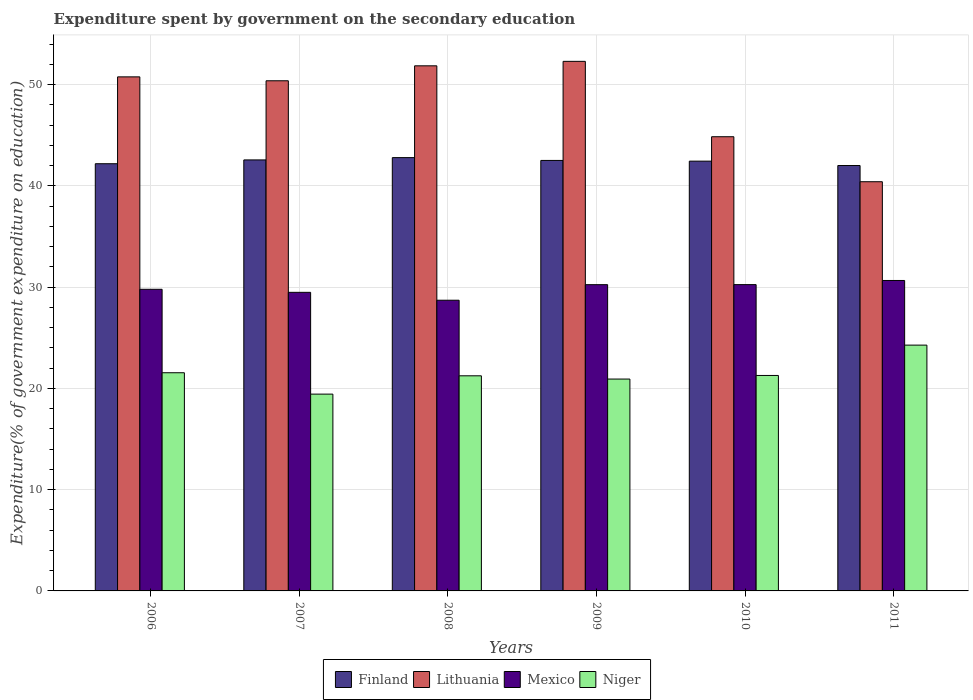Are the number of bars on each tick of the X-axis equal?
Your answer should be very brief. Yes. What is the label of the 5th group of bars from the left?
Keep it short and to the point. 2010. In how many cases, is the number of bars for a given year not equal to the number of legend labels?
Give a very brief answer. 0. What is the expenditure spent by government on the secondary education in Mexico in 2006?
Offer a terse response. 29.79. Across all years, what is the maximum expenditure spent by government on the secondary education in Niger?
Provide a succinct answer. 24.28. Across all years, what is the minimum expenditure spent by government on the secondary education in Lithuania?
Offer a terse response. 40.42. In which year was the expenditure spent by government on the secondary education in Lithuania minimum?
Provide a succinct answer. 2011. What is the total expenditure spent by government on the secondary education in Mexico in the graph?
Offer a terse response. 179.16. What is the difference between the expenditure spent by government on the secondary education in Lithuania in 2008 and that in 2011?
Make the answer very short. 11.45. What is the difference between the expenditure spent by government on the secondary education in Niger in 2007 and the expenditure spent by government on the secondary education in Mexico in 2010?
Your answer should be compact. -10.82. What is the average expenditure spent by government on the secondary education in Finland per year?
Offer a very short reply. 42.42. In the year 2010, what is the difference between the expenditure spent by government on the secondary education in Finland and expenditure spent by government on the secondary education in Mexico?
Offer a very short reply. 12.19. What is the ratio of the expenditure spent by government on the secondary education in Niger in 2006 to that in 2008?
Offer a terse response. 1.01. Is the difference between the expenditure spent by government on the secondary education in Finland in 2008 and 2011 greater than the difference between the expenditure spent by government on the secondary education in Mexico in 2008 and 2011?
Your answer should be compact. Yes. What is the difference between the highest and the second highest expenditure spent by government on the secondary education in Lithuania?
Make the answer very short. 0.44. What is the difference between the highest and the lowest expenditure spent by government on the secondary education in Mexico?
Provide a succinct answer. 1.95. Is the sum of the expenditure spent by government on the secondary education in Finland in 2006 and 2007 greater than the maximum expenditure spent by government on the secondary education in Niger across all years?
Your response must be concise. Yes. Is it the case that in every year, the sum of the expenditure spent by government on the secondary education in Lithuania and expenditure spent by government on the secondary education in Niger is greater than the sum of expenditure spent by government on the secondary education in Mexico and expenditure spent by government on the secondary education in Finland?
Your answer should be very brief. Yes. What does the 2nd bar from the left in 2011 represents?
Ensure brevity in your answer.  Lithuania. How many bars are there?
Your answer should be very brief. 24. How many years are there in the graph?
Ensure brevity in your answer.  6. What is the difference between two consecutive major ticks on the Y-axis?
Give a very brief answer. 10. What is the title of the graph?
Provide a succinct answer. Expenditure spent by government on the secondary education. What is the label or title of the Y-axis?
Offer a terse response. Expenditure(% of government expenditure on education). What is the Expenditure(% of government expenditure on education) of Finland in 2006?
Offer a terse response. 42.19. What is the Expenditure(% of government expenditure on education) in Lithuania in 2006?
Ensure brevity in your answer.  50.77. What is the Expenditure(% of government expenditure on education) of Mexico in 2006?
Ensure brevity in your answer.  29.79. What is the Expenditure(% of government expenditure on education) of Niger in 2006?
Give a very brief answer. 21.55. What is the Expenditure(% of government expenditure on education) in Finland in 2007?
Offer a terse response. 42.57. What is the Expenditure(% of government expenditure on education) in Lithuania in 2007?
Offer a terse response. 50.39. What is the Expenditure(% of government expenditure on education) in Mexico in 2007?
Your answer should be compact. 29.49. What is the Expenditure(% of government expenditure on education) of Niger in 2007?
Provide a short and direct response. 19.44. What is the Expenditure(% of government expenditure on education) in Finland in 2008?
Give a very brief answer. 42.8. What is the Expenditure(% of government expenditure on education) in Lithuania in 2008?
Keep it short and to the point. 51.86. What is the Expenditure(% of government expenditure on education) of Mexico in 2008?
Give a very brief answer. 28.71. What is the Expenditure(% of government expenditure on education) in Niger in 2008?
Provide a short and direct response. 21.25. What is the Expenditure(% of government expenditure on education) of Finland in 2009?
Your answer should be compact. 42.52. What is the Expenditure(% of government expenditure on education) of Lithuania in 2009?
Your answer should be very brief. 52.3. What is the Expenditure(% of government expenditure on education) in Mexico in 2009?
Give a very brief answer. 30.25. What is the Expenditure(% of government expenditure on education) of Niger in 2009?
Make the answer very short. 20.93. What is the Expenditure(% of government expenditure on education) of Finland in 2010?
Your answer should be very brief. 42.45. What is the Expenditure(% of government expenditure on education) of Lithuania in 2010?
Your response must be concise. 44.86. What is the Expenditure(% of government expenditure on education) of Mexico in 2010?
Give a very brief answer. 30.25. What is the Expenditure(% of government expenditure on education) in Niger in 2010?
Your answer should be compact. 21.28. What is the Expenditure(% of government expenditure on education) in Finland in 2011?
Your response must be concise. 42.02. What is the Expenditure(% of government expenditure on education) in Lithuania in 2011?
Your answer should be very brief. 40.42. What is the Expenditure(% of government expenditure on education) in Mexico in 2011?
Make the answer very short. 30.66. What is the Expenditure(% of government expenditure on education) of Niger in 2011?
Offer a terse response. 24.28. Across all years, what is the maximum Expenditure(% of government expenditure on education) in Finland?
Keep it short and to the point. 42.8. Across all years, what is the maximum Expenditure(% of government expenditure on education) of Lithuania?
Ensure brevity in your answer.  52.3. Across all years, what is the maximum Expenditure(% of government expenditure on education) in Mexico?
Give a very brief answer. 30.66. Across all years, what is the maximum Expenditure(% of government expenditure on education) of Niger?
Offer a very short reply. 24.28. Across all years, what is the minimum Expenditure(% of government expenditure on education) in Finland?
Keep it short and to the point. 42.02. Across all years, what is the minimum Expenditure(% of government expenditure on education) in Lithuania?
Your answer should be compact. 40.42. Across all years, what is the minimum Expenditure(% of government expenditure on education) in Mexico?
Your answer should be very brief. 28.71. Across all years, what is the minimum Expenditure(% of government expenditure on education) in Niger?
Your answer should be compact. 19.44. What is the total Expenditure(% of government expenditure on education) of Finland in the graph?
Offer a very short reply. 254.54. What is the total Expenditure(% of government expenditure on education) in Lithuania in the graph?
Provide a short and direct response. 290.6. What is the total Expenditure(% of government expenditure on education) of Mexico in the graph?
Provide a short and direct response. 179.16. What is the total Expenditure(% of government expenditure on education) in Niger in the graph?
Make the answer very short. 128.72. What is the difference between the Expenditure(% of government expenditure on education) in Finland in 2006 and that in 2007?
Your response must be concise. -0.38. What is the difference between the Expenditure(% of government expenditure on education) in Lithuania in 2006 and that in 2007?
Provide a short and direct response. 0.39. What is the difference between the Expenditure(% of government expenditure on education) of Mexico in 2006 and that in 2007?
Your response must be concise. 0.3. What is the difference between the Expenditure(% of government expenditure on education) of Niger in 2006 and that in 2007?
Your answer should be compact. 2.11. What is the difference between the Expenditure(% of government expenditure on education) of Finland in 2006 and that in 2008?
Offer a very short reply. -0.6. What is the difference between the Expenditure(% of government expenditure on education) of Lithuania in 2006 and that in 2008?
Offer a terse response. -1.09. What is the difference between the Expenditure(% of government expenditure on education) in Mexico in 2006 and that in 2008?
Give a very brief answer. 1.08. What is the difference between the Expenditure(% of government expenditure on education) of Niger in 2006 and that in 2008?
Provide a short and direct response. 0.3. What is the difference between the Expenditure(% of government expenditure on education) in Finland in 2006 and that in 2009?
Make the answer very short. -0.32. What is the difference between the Expenditure(% of government expenditure on education) in Lithuania in 2006 and that in 2009?
Provide a succinct answer. -1.53. What is the difference between the Expenditure(% of government expenditure on education) of Mexico in 2006 and that in 2009?
Keep it short and to the point. -0.46. What is the difference between the Expenditure(% of government expenditure on education) of Niger in 2006 and that in 2009?
Make the answer very short. 0.62. What is the difference between the Expenditure(% of government expenditure on education) of Finland in 2006 and that in 2010?
Offer a terse response. -0.25. What is the difference between the Expenditure(% of government expenditure on education) in Lithuania in 2006 and that in 2010?
Provide a short and direct response. 5.91. What is the difference between the Expenditure(% of government expenditure on education) of Mexico in 2006 and that in 2010?
Give a very brief answer. -0.46. What is the difference between the Expenditure(% of government expenditure on education) in Niger in 2006 and that in 2010?
Provide a short and direct response. 0.27. What is the difference between the Expenditure(% of government expenditure on education) in Finland in 2006 and that in 2011?
Make the answer very short. 0.18. What is the difference between the Expenditure(% of government expenditure on education) in Lithuania in 2006 and that in 2011?
Your response must be concise. 10.36. What is the difference between the Expenditure(% of government expenditure on education) of Mexico in 2006 and that in 2011?
Provide a succinct answer. -0.87. What is the difference between the Expenditure(% of government expenditure on education) in Niger in 2006 and that in 2011?
Provide a short and direct response. -2.73. What is the difference between the Expenditure(% of government expenditure on education) in Finland in 2007 and that in 2008?
Provide a succinct answer. -0.23. What is the difference between the Expenditure(% of government expenditure on education) of Lithuania in 2007 and that in 2008?
Provide a short and direct response. -1.48. What is the difference between the Expenditure(% of government expenditure on education) in Mexico in 2007 and that in 2008?
Give a very brief answer. 0.78. What is the difference between the Expenditure(% of government expenditure on education) in Niger in 2007 and that in 2008?
Offer a terse response. -1.81. What is the difference between the Expenditure(% of government expenditure on education) of Finland in 2007 and that in 2009?
Offer a very short reply. 0.05. What is the difference between the Expenditure(% of government expenditure on education) of Lithuania in 2007 and that in 2009?
Provide a short and direct response. -1.92. What is the difference between the Expenditure(% of government expenditure on education) of Mexico in 2007 and that in 2009?
Give a very brief answer. -0.76. What is the difference between the Expenditure(% of government expenditure on education) in Niger in 2007 and that in 2009?
Provide a succinct answer. -1.49. What is the difference between the Expenditure(% of government expenditure on education) of Finland in 2007 and that in 2010?
Offer a very short reply. 0.12. What is the difference between the Expenditure(% of government expenditure on education) in Lithuania in 2007 and that in 2010?
Provide a succinct answer. 5.53. What is the difference between the Expenditure(% of government expenditure on education) in Mexico in 2007 and that in 2010?
Your response must be concise. -0.76. What is the difference between the Expenditure(% of government expenditure on education) in Niger in 2007 and that in 2010?
Offer a very short reply. -1.84. What is the difference between the Expenditure(% of government expenditure on education) of Finland in 2007 and that in 2011?
Your answer should be compact. 0.55. What is the difference between the Expenditure(% of government expenditure on education) of Lithuania in 2007 and that in 2011?
Offer a terse response. 9.97. What is the difference between the Expenditure(% of government expenditure on education) of Mexico in 2007 and that in 2011?
Make the answer very short. -1.17. What is the difference between the Expenditure(% of government expenditure on education) of Niger in 2007 and that in 2011?
Make the answer very short. -4.84. What is the difference between the Expenditure(% of government expenditure on education) in Finland in 2008 and that in 2009?
Your response must be concise. 0.28. What is the difference between the Expenditure(% of government expenditure on education) in Lithuania in 2008 and that in 2009?
Give a very brief answer. -0.44. What is the difference between the Expenditure(% of government expenditure on education) in Mexico in 2008 and that in 2009?
Your answer should be compact. -1.54. What is the difference between the Expenditure(% of government expenditure on education) in Niger in 2008 and that in 2009?
Your answer should be very brief. 0.32. What is the difference between the Expenditure(% of government expenditure on education) in Finland in 2008 and that in 2010?
Offer a very short reply. 0.35. What is the difference between the Expenditure(% of government expenditure on education) of Lithuania in 2008 and that in 2010?
Provide a short and direct response. 7. What is the difference between the Expenditure(% of government expenditure on education) of Mexico in 2008 and that in 2010?
Offer a terse response. -1.54. What is the difference between the Expenditure(% of government expenditure on education) in Niger in 2008 and that in 2010?
Your answer should be very brief. -0.03. What is the difference between the Expenditure(% of government expenditure on education) in Finland in 2008 and that in 2011?
Provide a short and direct response. 0.78. What is the difference between the Expenditure(% of government expenditure on education) in Lithuania in 2008 and that in 2011?
Make the answer very short. 11.45. What is the difference between the Expenditure(% of government expenditure on education) in Mexico in 2008 and that in 2011?
Your answer should be compact. -1.95. What is the difference between the Expenditure(% of government expenditure on education) in Niger in 2008 and that in 2011?
Provide a succinct answer. -3.03. What is the difference between the Expenditure(% of government expenditure on education) in Finland in 2009 and that in 2010?
Ensure brevity in your answer.  0.07. What is the difference between the Expenditure(% of government expenditure on education) of Lithuania in 2009 and that in 2010?
Keep it short and to the point. 7.45. What is the difference between the Expenditure(% of government expenditure on education) of Mexico in 2009 and that in 2010?
Offer a very short reply. -0.01. What is the difference between the Expenditure(% of government expenditure on education) in Niger in 2009 and that in 2010?
Offer a terse response. -0.35. What is the difference between the Expenditure(% of government expenditure on education) of Finland in 2009 and that in 2011?
Keep it short and to the point. 0.5. What is the difference between the Expenditure(% of government expenditure on education) in Lithuania in 2009 and that in 2011?
Make the answer very short. 11.89. What is the difference between the Expenditure(% of government expenditure on education) of Mexico in 2009 and that in 2011?
Your answer should be very brief. -0.41. What is the difference between the Expenditure(% of government expenditure on education) of Niger in 2009 and that in 2011?
Your answer should be very brief. -3.35. What is the difference between the Expenditure(% of government expenditure on education) of Finland in 2010 and that in 2011?
Keep it short and to the point. 0.43. What is the difference between the Expenditure(% of government expenditure on education) in Lithuania in 2010 and that in 2011?
Ensure brevity in your answer.  4.44. What is the difference between the Expenditure(% of government expenditure on education) of Mexico in 2010 and that in 2011?
Your response must be concise. -0.41. What is the difference between the Expenditure(% of government expenditure on education) in Niger in 2010 and that in 2011?
Keep it short and to the point. -3. What is the difference between the Expenditure(% of government expenditure on education) of Finland in 2006 and the Expenditure(% of government expenditure on education) of Lithuania in 2007?
Ensure brevity in your answer.  -8.19. What is the difference between the Expenditure(% of government expenditure on education) of Finland in 2006 and the Expenditure(% of government expenditure on education) of Mexico in 2007?
Your answer should be very brief. 12.7. What is the difference between the Expenditure(% of government expenditure on education) of Finland in 2006 and the Expenditure(% of government expenditure on education) of Niger in 2007?
Offer a very short reply. 22.76. What is the difference between the Expenditure(% of government expenditure on education) in Lithuania in 2006 and the Expenditure(% of government expenditure on education) in Mexico in 2007?
Offer a terse response. 21.28. What is the difference between the Expenditure(% of government expenditure on education) of Lithuania in 2006 and the Expenditure(% of government expenditure on education) of Niger in 2007?
Provide a short and direct response. 31.33. What is the difference between the Expenditure(% of government expenditure on education) of Mexico in 2006 and the Expenditure(% of government expenditure on education) of Niger in 2007?
Make the answer very short. 10.35. What is the difference between the Expenditure(% of government expenditure on education) of Finland in 2006 and the Expenditure(% of government expenditure on education) of Lithuania in 2008?
Offer a terse response. -9.67. What is the difference between the Expenditure(% of government expenditure on education) in Finland in 2006 and the Expenditure(% of government expenditure on education) in Mexico in 2008?
Your answer should be very brief. 13.48. What is the difference between the Expenditure(% of government expenditure on education) of Finland in 2006 and the Expenditure(% of government expenditure on education) of Niger in 2008?
Your response must be concise. 20.95. What is the difference between the Expenditure(% of government expenditure on education) of Lithuania in 2006 and the Expenditure(% of government expenditure on education) of Mexico in 2008?
Keep it short and to the point. 22.06. What is the difference between the Expenditure(% of government expenditure on education) of Lithuania in 2006 and the Expenditure(% of government expenditure on education) of Niger in 2008?
Give a very brief answer. 29.53. What is the difference between the Expenditure(% of government expenditure on education) in Mexico in 2006 and the Expenditure(% of government expenditure on education) in Niger in 2008?
Your answer should be very brief. 8.54. What is the difference between the Expenditure(% of government expenditure on education) in Finland in 2006 and the Expenditure(% of government expenditure on education) in Lithuania in 2009?
Provide a short and direct response. -10.11. What is the difference between the Expenditure(% of government expenditure on education) in Finland in 2006 and the Expenditure(% of government expenditure on education) in Mexico in 2009?
Keep it short and to the point. 11.95. What is the difference between the Expenditure(% of government expenditure on education) in Finland in 2006 and the Expenditure(% of government expenditure on education) in Niger in 2009?
Provide a succinct answer. 21.27. What is the difference between the Expenditure(% of government expenditure on education) of Lithuania in 2006 and the Expenditure(% of government expenditure on education) of Mexico in 2009?
Give a very brief answer. 20.52. What is the difference between the Expenditure(% of government expenditure on education) of Lithuania in 2006 and the Expenditure(% of government expenditure on education) of Niger in 2009?
Offer a terse response. 29.85. What is the difference between the Expenditure(% of government expenditure on education) of Mexico in 2006 and the Expenditure(% of government expenditure on education) of Niger in 2009?
Make the answer very short. 8.86. What is the difference between the Expenditure(% of government expenditure on education) in Finland in 2006 and the Expenditure(% of government expenditure on education) in Lithuania in 2010?
Offer a terse response. -2.67. What is the difference between the Expenditure(% of government expenditure on education) in Finland in 2006 and the Expenditure(% of government expenditure on education) in Mexico in 2010?
Ensure brevity in your answer.  11.94. What is the difference between the Expenditure(% of government expenditure on education) of Finland in 2006 and the Expenditure(% of government expenditure on education) of Niger in 2010?
Ensure brevity in your answer.  20.91. What is the difference between the Expenditure(% of government expenditure on education) of Lithuania in 2006 and the Expenditure(% of government expenditure on education) of Mexico in 2010?
Provide a short and direct response. 20.52. What is the difference between the Expenditure(% of government expenditure on education) of Lithuania in 2006 and the Expenditure(% of government expenditure on education) of Niger in 2010?
Offer a very short reply. 29.49. What is the difference between the Expenditure(% of government expenditure on education) in Mexico in 2006 and the Expenditure(% of government expenditure on education) in Niger in 2010?
Give a very brief answer. 8.51. What is the difference between the Expenditure(% of government expenditure on education) in Finland in 2006 and the Expenditure(% of government expenditure on education) in Lithuania in 2011?
Your response must be concise. 1.78. What is the difference between the Expenditure(% of government expenditure on education) of Finland in 2006 and the Expenditure(% of government expenditure on education) of Mexico in 2011?
Your answer should be very brief. 11.53. What is the difference between the Expenditure(% of government expenditure on education) in Finland in 2006 and the Expenditure(% of government expenditure on education) in Niger in 2011?
Offer a terse response. 17.92. What is the difference between the Expenditure(% of government expenditure on education) in Lithuania in 2006 and the Expenditure(% of government expenditure on education) in Mexico in 2011?
Your answer should be very brief. 20.11. What is the difference between the Expenditure(% of government expenditure on education) of Lithuania in 2006 and the Expenditure(% of government expenditure on education) of Niger in 2011?
Offer a terse response. 26.5. What is the difference between the Expenditure(% of government expenditure on education) of Mexico in 2006 and the Expenditure(% of government expenditure on education) of Niger in 2011?
Keep it short and to the point. 5.51. What is the difference between the Expenditure(% of government expenditure on education) in Finland in 2007 and the Expenditure(% of government expenditure on education) in Lithuania in 2008?
Provide a short and direct response. -9.29. What is the difference between the Expenditure(% of government expenditure on education) of Finland in 2007 and the Expenditure(% of government expenditure on education) of Mexico in 2008?
Your answer should be compact. 13.86. What is the difference between the Expenditure(% of government expenditure on education) of Finland in 2007 and the Expenditure(% of government expenditure on education) of Niger in 2008?
Offer a terse response. 21.32. What is the difference between the Expenditure(% of government expenditure on education) of Lithuania in 2007 and the Expenditure(% of government expenditure on education) of Mexico in 2008?
Provide a short and direct response. 21.68. What is the difference between the Expenditure(% of government expenditure on education) of Lithuania in 2007 and the Expenditure(% of government expenditure on education) of Niger in 2008?
Your answer should be very brief. 29.14. What is the difference between the Expenditure(% of government expenditure on education) in Mexico in 2007 and the Expenditure(% of government expenditure on education) in Niger in 2008?
Offer a terse response. 8.24. What is the difference between the Expenditure(% of government expenditure on education) of Finland in 2007 and the Expenditure(% of government expenditure on education) of Lithuania in 2009?
Your answer should be very brief. -9.74. What is the difference between the Expenditure(% of government expenditure on education) in Finland in 2007 and the Expenditure(% of government expenditure on education) in Mexico in 2009?
Offer a very short reply. 12.32. What is the difference between the Expenditure(% of government expenditure on education) of Finland in 2007 and the Expenditure(% of government expenditure on education) of Niger in 2009?
Your answer should be very brief. 21.64. What is the difference between the Expenditure(% of government expenditure on education) in Lithuania in 2007 and the Expenditure(% of government expenditure on education) in Mexico in 2009?
Keep it short and to the point. 20.14. What is the difference between the Expenditure(% of government expenditure on education) in Lithuania in 2007 and the Expenditure(% of government expenditure on education) in Niger in 2009?
Ensure brevity in your answer.  29.46. What is the difference between the Expenditure(% of government expenditure on education) of Mexico in 2007 and the Expenditure(% of government expenditure on education) of Niger in 2009?
Offer a terse response. 8.56. What is the difference between the Expenditure(% of government expenditure on education) in Finland in 2007 and the Expenditure(% of government expenditure on education) in Lithuania in 2010?
Your answer should be very brief. -2.29. What is the difference between the Expenditure(% of government expenditure on education) of Finland in 2007 and the Expenditure(% of government expenditure on education) of Mexico in 2010?
Give a very brief answer. 12.32. What is the difference between the Expenditure(% of government expenditure on education) in Finland in 2007 and the Expenditure(% of government expenditure on education) in Niger in 2010?
Keep it short and to the point. 21.29. What is the difference between the Expenditure(% of government expenditure on education) in Lithuania in 2007 and the Expenditure(% of government expenditure on education) in Mexico in 2010?
Make the answer very short. 20.13. What is the difference between the Expenditure(% of government expenditure on education) of Lithuania in 2007 and the Expenditure(% of government expenditure on education) of Niger in 2010?
Provide a succinct answer. 29.11. What is the difference between the Expenditure(% of government expenditure on education) in Mexico in 2007 and the Expenditure(% of government expenditure on education) in Niger in 2010?
Ensure brevity in your answer.  8.21. What is the difference between the Expenditure(% of government expenditure on education) in Finland in 2007 and the Expenditure(% of government expenditure on education) in Lithuania in 2011?
Ensure brevity in your answer.  2.15. What is the difference between the Expenditure(% of government expenditure on education) of Finland in 2007 and the Expenditure(% of government expenditure on education) of Mexico in 2011?
Keep it short and to the point. 11.91. What is the difference between the Expenditure(% of government expenditure on education) in Finland in 2007 and the Expenditure(% of government expenditure on education) in Niger in 2011?
Offer a terse response. 18.29. What is the difference between the Expenditure(% of government expenditure on education) in Lithuania in 2007 and the Expenditure(% of government expenditure on education) in Mexico in 2011?
Your response must be concise. 19.72. What is the difference between the Expenditure(% of government expenditure on education) of Lithuania in 2007 and the Expenditure(% of government expenditure on education) of Niger in 2011?
Provide a short and direct response. 26.11. What is the difference between the Expenditure(% of government expenditure on education) of Mexico in 2007 and the Expenditure(% of government expenditure on education) of Niger in 2011?
Provide a succinct answer. 5.21. What is the difference between the Expenditure(% of government expenditure on education) of Finland in 2008 and the Expenditure(% of government expenditure on education) of Lithuania in 2009?
Make the answer very short. -9.51. What is the difference between the Expenditure(% of government expenditure on education) in Finland in 2008 and the Expenditure(% of government expenditure on education) in Mexico in 2009?
Your response must be concise. 12.55. What is the difference between the Expenditure(% of government expenditure on education) in Finland in 2008 and the Expenditure(% of government expenditure on education) in Niger in 2009?
Give a very brief answer. 21.87. What is the difference between the Expenditure(% of government expenditure on education) in Lithuania in 2008 and the Expenditure(% of government expenditure on education) in Mexico in 2009?
Offer a terse response. 21.61. What is the difference between the Expenditure(% of government expenditure on education) of Lithuania in 2008 and the Expenditure(% of government expenditure on education) of Niger in 2009?
Your answer should be very brief. 30.94. What is the difference between the Expenditure(% of government expenditure on education) in Mexico in 2008 and the Expenditure(% of government expenditure on education) in Niger in 2009?
Provide a succinct answer. 7.79. What is the difference between the Expenditure(% of government expenditure on education) in Finland in 2008 and the Expenditure(% of government expenditure on education) in Lithuania in 2010?
Your answer should be compact. -2.06. What is the difference between the Expenditure(% of government expenditure on education) in Finland in 2008 and the Expenditure(% of government expenditure on education) in Mexico in 2010?
Keep it short and to the point. 12.54. What is the difference between the Expenditure(% of government expenditure on education) in Finland in 2008 and the Expenditure(% of government expenditure on education) in Niger in 2010?
Provide a succinct answer. 21.52. What is the difference between the Expenditure(% of government expenditure on education) of Lithuania in 2008 and the Expenditure(% of government expenditure on education) of Mexico in 2010?
Keep it short and to the point. 21.61. What is the difference between the Expenditure(% of government expenditure on education) of Lithuania in 2008 and the Expenditure(% of government expenditure on education) of Niger in 2010?
Make the answer very short. 30.58. What is the difference between the Expenditure(% of government expenditure on education) in Mexico in 2008 and the Expenditure(% of government expenditure on education) in Niger in 2010?
Provide a succinct answer. 7.43. What is the difference between the Expenditure(% of government expenditure on education) of Finland in 2008 and the Expenditure(% of government expenditure on education) of Lithuania in 2011?
Ensure brevity in your answer.  2.38. What is the difference between the Expenditure(% of government expenditure on education) in Finland in 2008 and the Expenditure(% of government expenditure on education) in Mexico in 2011?
Your answer should be compact. 12.13. What is the difference between the Expenditure(% of government expenditure on education) of Finland in 2008 and the Expenditure(% of government expenditure on education) of Niger in 2011?
Offer a very short reply. 18.52. What is the difference between the Expenditure(% of government expenditure on education) of Lithuania in 2008 and the Expenditure(% of government expenditure on education) of Mexico in 2011?
Ensure brevity in your answer.  21.2. What is the difference between the Expenditure(% of government expenditure on education) of Lithuania in 2008 and the Expenditure(% of government expenditure on education) of Niger in 2011?
Make the answer very short. 27.58. What is the difference between the Expenditure(% of government expenditure on education) in Mexico in 2008 and the Expenditure(% of government expenditure on education) in Niger in 2011?
Offer a terse response. 4.43. What is the difference between the Expenditure(% of government expenditure on education) in Finland in 2009 and the Expenditure(% of government expenditure on education) in Lithuania in 2010?
Offer a very short reply. -2.34. What is the difference between the Expenditure(% of government expenditure on education) of Finland in 2009 and the Expenditure(% of government expenditure on education) of Mexico in 2010?
Offer a very short reply. 12.26. What is the difference between the Expenditure(% of government expenditure on education) in Finland in 2009 and the Expenditure(% of government expenditure on education) in Niger in 2010?
Give a very brief answer. 21.24. What is the difference between the Expenditure(% of government expenditure on education) of Lithuania in 2009 and the Expenditure(% of government expenditure on education) of Mexico in 2010?
Provide a short and direct response. 22.05. What is the difference between the Expenditure(% of government expenditure on education) in Lithuania in 2009 and the Expenditure(% of government expenditure on education) in Niger in 2010?
Your response must be concise. 31.02. What is the difference between the Expenditure(% of government expenditure on education) in Mexico in 2009 and the Expenditure(% of government expenditure on education) in Niger in 2010?
Give a very brief answer. 8.97. What is the difference between the Expenditure(% of government expenditure on education) of Finland in 2009 and the Expenditure(% of government expenditure on education) of Lithuania in 2011?
Keep it short and to the point. 2.1. What is the difference between the Expenditure(% of government expenditure on education) in Finland in 2009 and the Expenditure(% of government expenditure on education) in Mexico in 2011?
Ensure brevity in your answer.  11.86. What is the difference between the Expenditure(% of government expenditure on education) in Finland in 2009 and the Expenditure(% of government expenditure on education) in Niger in 2011?
Make the answer very short. 18.24. What is the difference between the Expenditure(% of government expenditure on education) in Lithuania in 2009 and the Expenditure(% of government expenditure on education) in Mexico in 2011?
Offer a very short reply. 21.64. What is the difference between the Expenditure(% of government expenditure on education) of Lithuania in 2009 and the Expenditure(% of government expenditure on education) of Niger in 2011?
Provide a short and direct response. 28.03. What is the difference between the Expenditure(% of government expenditure on education) of Mexico in 2009 and the Expenditure(% of government expenditure on education) of Niger in 2011?
Offer a terse response. 5.97. What is the difference between the Expenditure(% of government expenditure on education) of Finland in 2010 and the Expenditure(% of government expenditure on education) of Lithuania in 2011?
Offer a very short reply. 2.03. What is the difference between the Expenditure(% of government expenditure on education) of Finland in 2010 and the Expenditure(% of government expenditure on education) of Mexico in 2011?
Ensure brevity in your answer.  11.79. What is the difference between the Expenditure(% of government expenditure on education) of Finland in 2010 and the Expenditure(% of government expenditure on education) of Niger in 2011?
Make the answer very short. 18.17. What is the difference between the Expenditure(% of government expenditure on education) in Lithuania in 2010 and the Expenditure(% of government expenditure on education) in Mexico in 2011?
Offer a very short reply. 14.2. What is the difference between the Expenditure(% of government expenditure on education) in Lithuania in 2010 and the Expenditure(% of government expenditure on education) in Niger in 2011?
Offer a terse response. 20.58. What is the difference between the Expenditure(% of government expenditure on education) in Mexico in 2010 and the Expenditure(% of government expenditure on education) in Niger in 2011?
Provide a succinct answer. 5.98. What is the average Expenditure(% of government expenditure on education) of Finland per year?
Ensure brevity in your answer.  42.42. What is the average Expenditure(% of government expenditure on education) in Lithuania per year?
Offer a very short reply. 48.43. What is the average Expenditure(% of government expenditure on education) in Mexico per year?
Keep it short and to the point. 29.86. What is the average Expenditure(% of government expenditure on education) in Niger per year?
Make the answer very short. 21.45. In the year 2006, what is the difference between the Expenditure(% of government expenditure on education) of Finland and Expenditure(% of government expenditure on education) of Lithuania?
Your response must be concise. -8.58. In the year 2006, what is the difference between the Expenditure(% of government expenditure on education) in Finland and Expenditure(% of government expenditure on education) in Mexico?
Your answer should be very brief. 12.4. In the year 2006, what is the difference between the Expenditure(% of government expenditure on education) of Finland and Expenditure(% of government expenditure on education) of Niger?
Your answer should be very brief. 20.64. In the year 2006, what is the difference between the Expenditure(% of government expenditure on education) in Lithuania and Expenditure(% of government expenditure on education) in Mexico?
Provide a short and direct response. 20.98. In the year 2006, what is the difference between the Expenditure(% of government expenditure on education) of Lithuania and Expenditure(% of government expenditure on education) of Niger?
Provide a short and direct response. 29.22. In the year 2006, what is the difference between the Expenditure(% of government expenditure on education) in Mexico and Expenditure(% of government expenditure on education) in Niger?
Provide a short and direct response. 8.24. In the year 2007, what is the difference between the Expenditure(% of government expenditure on education) in Finland and Expenditure(% of government expenditure on education) in Lithuania?
Offer a terse response. -7.82. In the year 2007, what is the difference between the Expenditure(% of government expenditure on education) in Finland and Expenditure(% of government expenditure on education) in Mexico?
Give a very brief answer. 13.08. In the year 2007, what is the difference between the Expenditure(% of government expenditure on education) in Finland and Expenditure(% of government expenditure on education) in Niger?
Your answer should be very brief. 23.13. In the year 2007, what is the difference between the Expenditure(% of government expenditure on education) of Lithuania and Expenditure(% of government expenditure on education) of Mexico?
Provide a short and direct response. 20.9. In the year 2007, what is the difference between the Expenditure(% of government expenditure on education) of Lithuania and Expenditure(% of government expenditure on education) of Niger?
Ensure brevity in your answer.  30.95. In the year 2007, what is the difference between the Expenditure(% of government expenditure on education) in Mexico and Expenditure(% of government expenditure on education) in Niger?
Ensure brevity in your answer.  10.05. In the year 2008, what is the difference between the Expenditure(% of government expenditure on education) of Finland and Expenditure(% of government expenditure on education) of Lithuania?
Provide a short and direct response. -9.07. In the year 2008, what is the difference between the Expenditure(% of government expenditure on education) in Finland and Expenditure(% of government expenditure on education) in Mexico?
Your answer should be compact. 14.08. In the year 2008, what is the difference between the Expenditure(% of government expenditure on education) of Finland and Expenditure(% of government expenditure on education) of Niger?
Keep it short and to the point. 21.55. In the year 2008, what is the difference between the Expenditure(% of government expenditure on education) of Lithuania and Expenditure(% of government expenditure on education) of Mexico?
Your response must be concise. 23.15. In the year 2008, what is the difference between the Expenditure(% of government expenditure on education) of Lithuania and Expenditure(% of government expenditure on education) of Niger?
Your answer should be compact. 30.62. In the year 2008, what is the difference between the Expenditure(% of government expenditure on education) in Mexico and Expenditure(% of government expenditure on education) in Niger?
Provide a succinct answer. 7.46. In the year 2009, what is the difference between the Expenditure(% of government expenditure on education) of Finland and Expenditure(% of government expenditure on education) of Lithuania?
Keep it short and to the point. -9.79. In the year 2009, what is the difference between the Expenditure(% of government expenditure on education) in Finland and Expenditure(% of government expenditure on education) in Mexico?
Your answer should be compact. 12.27. In the year 2009, what is the difference between the Expenditure(% of government expenditure on education) in Finland and Expenditure(% of government expenditure on education) in Niger?
Provide a short and direct response. 21.59. In the year 2009, what is the difference between the Expenditure(% of government expenditure on education) in Lithuania and Expenditure(% of government expenditure on education) in Mexico?
Your response must be concise. 22.06. In the year 2009, what is the difference between the Expenditure(% of government expenditure on education) of Lithuania and Expenditure(% of government expenditure on education) of Niger?
Provide a succinct answer. 31.38. In the year 2009, what is the difference between the Expenditure(% of government expenditure on education) in Mexico and Expenditure(% of government expenditure on education) in Niger?
Ensure brevity in your answer.  9.32. In the year 2010, what is the difference between the Expenditure(% of government expenditure on education) in Finland and Expenditure(% of government expenditure on education) in Lithuania?
Offer a very short reply. -2.41. In the year 2010, what is the difference between the Expenditure(% of government expenditure on education) in Finland and Expenditure(% of government expenditure on education) in Mexico?
Your answer should be compact. 12.19. In the year 2010, what is the difference between the Expenditure(% of government expenditure on education) of Finland and Expenditure(% of government expenditure on education) of Niger?
Offer a terse response. 21.17. In the year 2010, what is the difference between the Expenditure(% of government expenditure on education) in Lithuania and Expenditure(% of government expenditure on education) in Mexico?
Keep it short and to the point. 14.61. In the year 2010, what is the difference between the Expenditure(% of government expenditure on education) in Lithuania and Expenditure(% of government expenditure on education) in Niger?
Give a very brief answer. 23.58. In the year 2010, what is the difference between the Expenditure(% of government expenditure on education) of Mexico and Expenditure(% of government expenditure on education) of Niger?
Provide a succinct answer. 8.97. In the year 2011, what is the difference between the Expenditure(% of government expenditure on education) in Finland and Expenditure(% of government expenditure on education) in Lithuania?
Provide a succinct answer. 1.6. In the year 2011, what is the difference between the Expenditure(% of government expenditure on education) in Finland and Expenditure(% of government expenditure on education) in Mexico?
Provide a succinct answer. 11.35. In the year 2011, what is the difference between the Expenditure(% of government expenditure on education) in Finland and Expenditure(% of government expenditure on education) in Niger?
Keep it short and to the point. 17.74. In the year 2011, what is the difference between the Expenditure(% of government expenditure on education) of Lithuania and Expenditure(% of government expenditure on education) of Mexico?
Your answer should be very brief. 9.75. In the year 2011, what is the difference between the Expenditure(% of government expenditure on education) of Lithuania and Expenditure(% of government expenditure on education) of Niger?
Your answer should be very brief. 16.14. In the year 2011, what is the difference between the Expenditure(% of government expenditure on education) in Mexico and Expenditure(% of government expenditure on education) in Niger?
Give a very brief answer. 6.38. What is the ratio of the Expenditure(% of government expenditure on education) in Finland in 2006 to that in 2007?
Provide a succinct answer. 0.99. What is the ratio of the Expenditure(% of government expenditure on education) of Lithuania in 2006 to that in 2007?
Your answer should be very brief. 1.01. What is the ratio of the Expenditure(% of government expenditure on education) in Mexico in 2006 to that in 2007?
Your response must be concise. 1.01. What is the ratio of the Expenditure(% of government expenditure on education) of Niger in 2006 to that in 2007?
Your response must be concise. 1.11. What is the ratio of the Expenditure(% of government expenditure on education) in Finland in 2006 to that in 2008?
Your response must be concise. 0.99. What is the ratio of the Expenditure(% of government expenditure on education) in Mexico in 2006 to that in 2008?
Your response must be concise. 1.04. What is the ratio of the Expenditure(% of government expenditure on education) of Niger in 2006 to that in 2008?
Provide a succinct answer. 1.01. What is the ratio of the Expenditure(% of government expenditure on education) of Lithuania in 2006 to that in 2009?
Provide a short and direct response. 0.97. What is the ratio of the Expenditure(% of government expenditure on education) of Mexico in 2006 to that in 2009?
Your answer should be compact. 0.98. What is the ratio of the Expenditure(% of government expenditure on education) in Niger in 2006 to that in 2009?
Provide a short and direct response. 1.03. What is the ratio of the Expenditure(% of government expenditure on education) in Finland in 2006 to that in 2010?
Your response must be concise. 0.99. What is the ratio of the Expenditure(% of government expenditure on education) in Lithuania in 2006 to that in 2010?
Provide a short and direct response. 1.13. What is the ratio of the Expenditure(% of government expenditure on education) in Mexico in 2006 to that in 2010?
Keep it short and to the point. 0.98. What is the ratio of the Expenditure(% of government expenditure on education) in Niger in 2006 to that in 2010?
Keep it short and to the point. 1.01. What is the ratio of the Expenditure(% of government expenditure on education) of Finland in 2006 to that in 2011?
Your answer should be very brief. 1. What is the ratio of the Expenditure(% of government expenditure on education) in Lithuania in 2006 to that in 2011?
Offer a terse response. 1.26. What is the ratio of the Expenditure(% of government expenditure on education) of Mexico in 2006 to that in 2011?
Give a very brief answer. 0.97. What is the ratio of the Expenditure(% of government expenditure on education) of Niger in 2006 to that in 2011?
Provide a succinct answer. 0.89. What is the ratio of the Expenditure(% of government expenditure on education) of Lithuania in 2007 to that in 2008?
Your answer should be very brief. 0.97. What is the ratio of the Expenditure(% of government expenditure on education) of Mexico in 2007 to that in 2008?
Keep it short and to the point. 1.03. What is the ratio of the Expenditure(% of government expenditure on education) in Niger in 2007 to that in 2008?
Keep it short and to the point. 0.91. What is the ratio of the Expenditure(% of government expenditure on education) in Lithuania in 2007 to that in 2009?
Your response must be concise. 0.96. What is the ratio of the Expenditure(% of government expenditure on education) of Mexico in 2007 to that in 2009?
Provide a succinct answer. 0.97. What is the ratio of the Expenditure(% of government expenditure on education) of Niger in 2007 to that in 2009?
Provide a succinct answer. 0.93. What is the ratio of the Expenditure(% of government expenditure on education) of Finland in 2007 to that in 2010?
Give a very brief answer. 1. What is the ratio of the Expenditure(% of government expenditure on education) in Lithuania in 2007 to that in 2010?
Your response must be concise. 1.12. What is the ratio of the Expenditure(% of government expenditure on education) in Mexico in 2007 to that in 2010?
Provide a succinct answer. 0.97. What is the ratio of the Expenditure(% of government expenditure on education) in Niger in 2007 to that in 2010?
Provide a succinct answer. 0.91. What is the ratio of the Expenditure(% of government expenditure on education) of Finland in 2007 to that in 2011?
Your answer should be compact. 1.01. What is the ratio of the Expenditure(% of government expenditure on education) in Lithuania in 2007 to that in 2011?
Keep it short and to the point. 1.25. What is the ratio of the Expenditure(% of government expenditure on education) in Mexico in 2007 to that in 2011?
Offer a terse response. 0.96. What is the ratio of the Expenditure(% of government expenditure on education) of Niger in 2007 to that in 2011?
Ensure brevity in your answer.  0.8. What is the ratio of the Expenditure(% of government expenditure on education) in Finland in 2008 to that in 2009?
Ensure brevity in your answer.  1.01. What is the ratio of the Expenditure(% of government expenditure on education) of Lithuania in 2008 to that in 2009?
Offer a terse response. 0.99. What is the ratio of the Expenditure(% of government expenditure on education) in Mexico in 2008 to that in 2009?
Your answer should be very brief. 0.95. What is the ratio of the Expenditure(% of government expenditure on education) in Niger in 2008 to that in 2009?
Offer a very short reply. 1.02. What is the ratio of the Expenditure(% of government expenditure on education) in Finland in 2008 to that in 2010?
Your answer should be very brief. 1.01. What is the ratio of the Expenditure(% of government expenditure on education) of Lithuania in 2008 to that in 2010?
Your answer should be compact. 1.16. What is the ratio of the Expenditure(% of government expenditure on education) of Mexico in 2008 to that in 2010?
Provide a short and direct response. 0.95. What is the ratio of the Expenditure(% of government expenditure on education) of Niger in 2008 to that in 2010?
Offer a terse response. 1. What is the ratio of the Expenditure(% of government expenditure on education) in Finland in 2008 to that in 2011?
Your answer should be compact. 1.02. What is the ratio of the Expenditure(% of government expenditure on education) of Lithuania in 2008 to that in 2011?
Offer a very short reply. 1.28. What is the ratio of the Expenditure(% of government expenditure on education) of Mexico in 2008 to that in 2011?
Your answer should be very brief. 0.94. What is the ratio of the Expenditure(% of government expenditure on education) of Niger in 2008 to that in 2011?
Ensure brevity in your answer.  0.88. What is the ratio of the Expenditure(% of government expenditure on education) of Lithuania in 2009 to that in 2010?
Your answer should be very brief. 1.17. What is the ratio of the Expenditure(% of government expenditure on education) of Niger in 2009 to that in 2010?
Make the answer very short. 0.98. What is the ratio of the Expenditure(% of government expenditure on education) of Finland in 2009 to that in 2011?
Your response must be concise. 1.01. What is the ratio of the Expenditure(% of government expenditure on education) of Lithuania in 2009 to that in 2011?
Provide a short and direct response. 1.29. What is the ratio of the Expenditure(% of government expenditure on education) in Mexico in 2009 to that in 2011?
Your response must be concise. 0.99. What is the ratio of the Expenditure(% of government expenditure on education) in Niger in 2009 to that in 2011?
Provide a succinct answer. 0.86. What is the ratio of the Expenditure(% of government expenditure on education) of Finland in 2010 to that in 2011?
Make the answer very short. 1.01. What is the ratio of the Expenditure(% of government expenditure on education) of Lithuania in 2010 to that in 2011?
Your answer should be compact. 1.11. What is the ratio of the Expenditure(% of government expenditure on education) of Mexico in 2010 to that in 2011?
Your answer should be compact. 0.99. What is the ratio of the Expenditure(% of government expenditure on education) of Niger in 2010 to that in 2011?
Provide a succinct answer. 0.88. What is the difference between the highest and the second highest Expenditure(% of government expenditure on education) of Finland?
Provide a succinct answer. 0.23. What is the difference between the highest and the second highest Expenditure(% of government expenditure on education) of Lithuania?
Your response must be concise. 0.44. What is the difference between the highest and the second highest Expenditure(% of government expenditure on education) in Mexico?
Give a very brief answer. 0.41. What is the difference between the highest and the second highest Expenditure(% of government expenditure on education) of Niger?
Provide a short and direct response. 2.73. What is the difference between the highest and the lowest Expenditure(% of government expenditure on education) of Finland?
Your answer should be compact. 0.78. What is the difference between the highest and the lowest Expenditure(% of government expenditure on education) in Lithuania?
Offer a terse response. 11.89. What is the difference between the highest and the lowest Expenditure(% of government expenditure on education) of Mexico?
Give a very brief answer. 1.95. What is the difference between the highest and the lowest Expenditure(% of government expenditure on education) of Niger?
Your response must be concise. 4.84. 